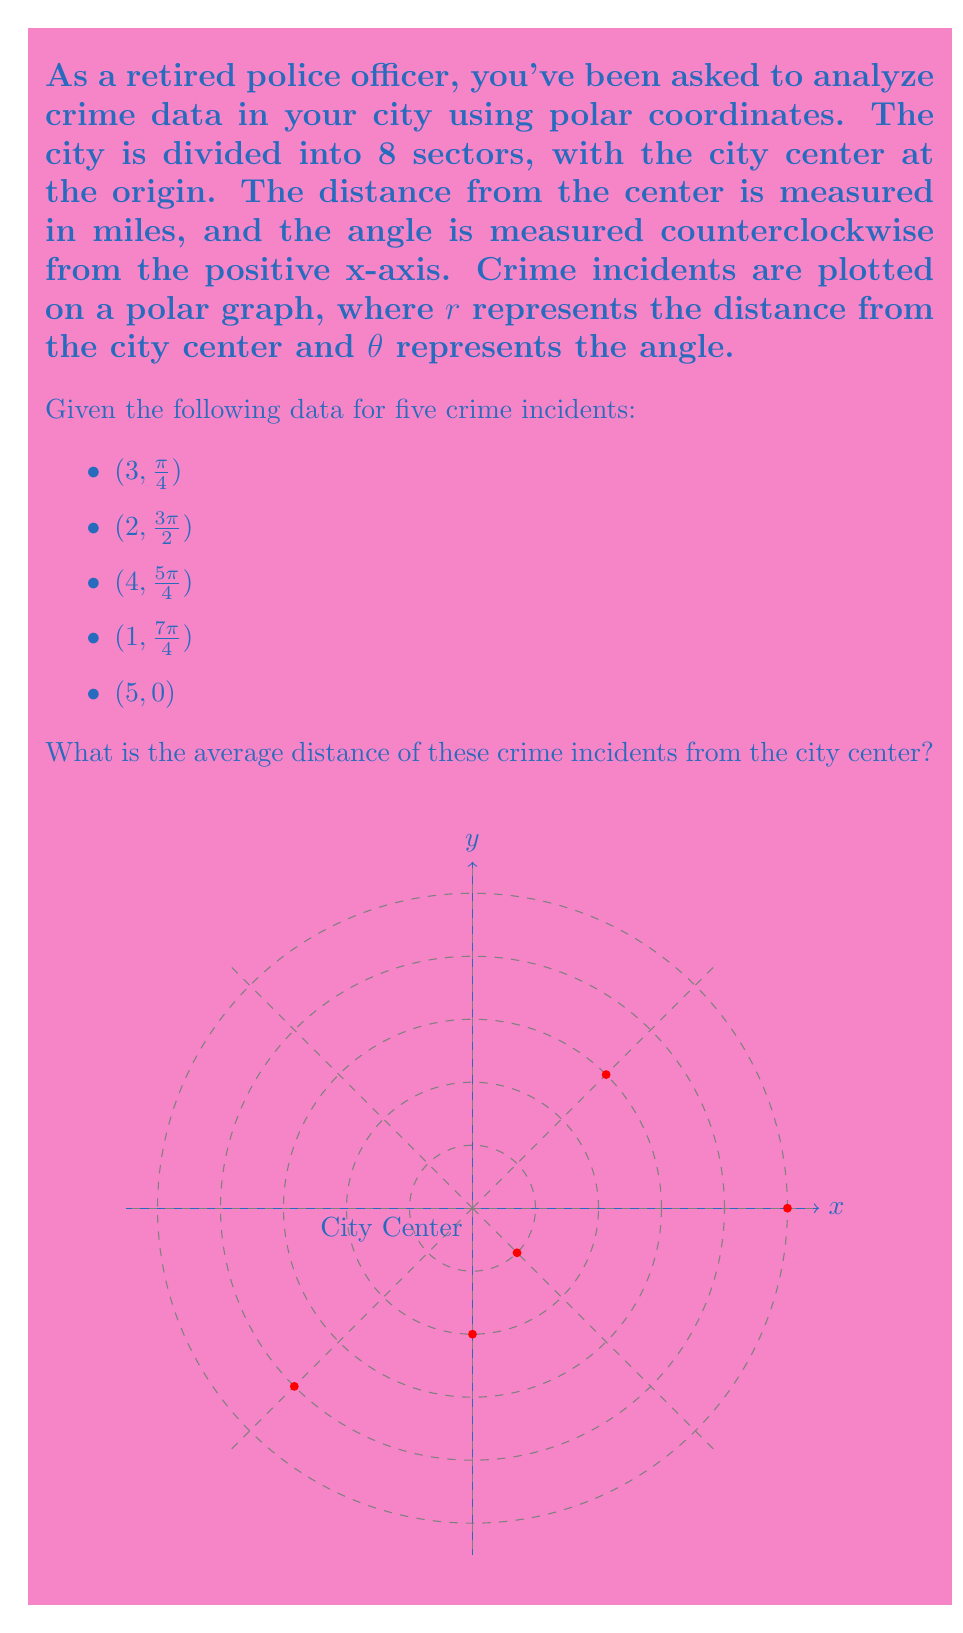Show me your answer to this math problem. To find the average distance of the crime incidents from the city center, we need to:

1. Identify the distances ($r$ values) for each incident
2. Calculate the sum of these distances
3. Divide the sum by the number of incidents

Step 1: Identify the distances
From the given data, we can extract the $r$ values:
1. $r_1 = 3$
2. $r_2 = 2$
3. $r_3 = 4$
4. $r_4 = 1$
5. $r_5 = 5$

Step 2: Calculate the sum of distances
$$\text{Sum} = r_1 + r_2 + r_3 + r_4 + r_5 = 3 + 2 + 4 + 1 + 5 = 15$$

Step 3: Calculate the average
The average distance is the sum divided by the number of incidents:

$$\text{Average distance} = \frac{\text{Sum of distances}}{\text{Number of incidents}} = \frac{15}{5} = 3$$

Therefore, the average distance of the crime incidents from the city center is 3 miles.
Answer: 3 miles 